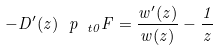<formula> <loc_0><loc_0><loc_500><loc_500>- D ^ { \prime } ( z ) \ p _ { \ t 0 } F = \frac { w ^ { \prime } ( z ) } { w ( z ) } - \frac { 1 } { z }</formula> 